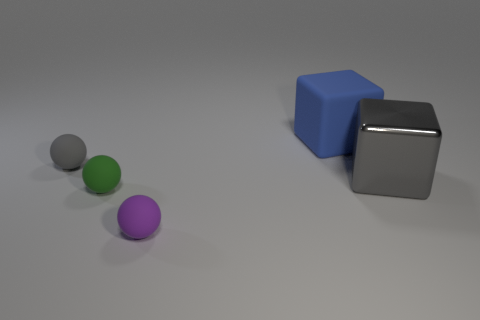Add 4 big blocks. How many objects exist? 9 Subtract all spheres. How many objects are left? 2 Add 2 large rubber cylinders. How many large rubber cylinders exist? 2 Subtract 1 blue cubes. How many objects are left? 4 Subtract all gray balls. Subtract all small matte balls. How many objects are left? 1 Add 1 purple spheres. How many purple spheres are left? 2 